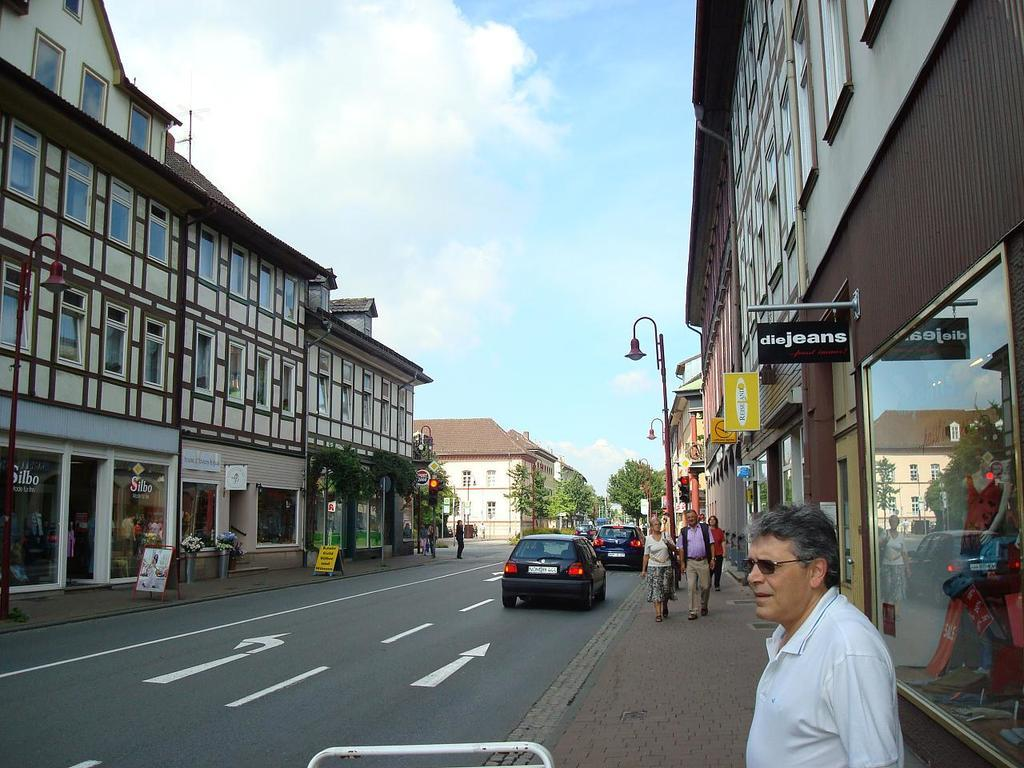What is happening on the road in the image? There are vehicles moving on the road in the image. What can be seen on the sides of the road? There are buildings visible on the sides of the road. What are the people doing in front of the buildings? There are people walking in front of the buildings. What level of difficulty is suggested by the image? The image does not suggest a level of difficulty, as it is a static representation of a scene. What minute of the day is depicted in the image? The image does not depict a specific minute of the day, as there is no indication of time. 